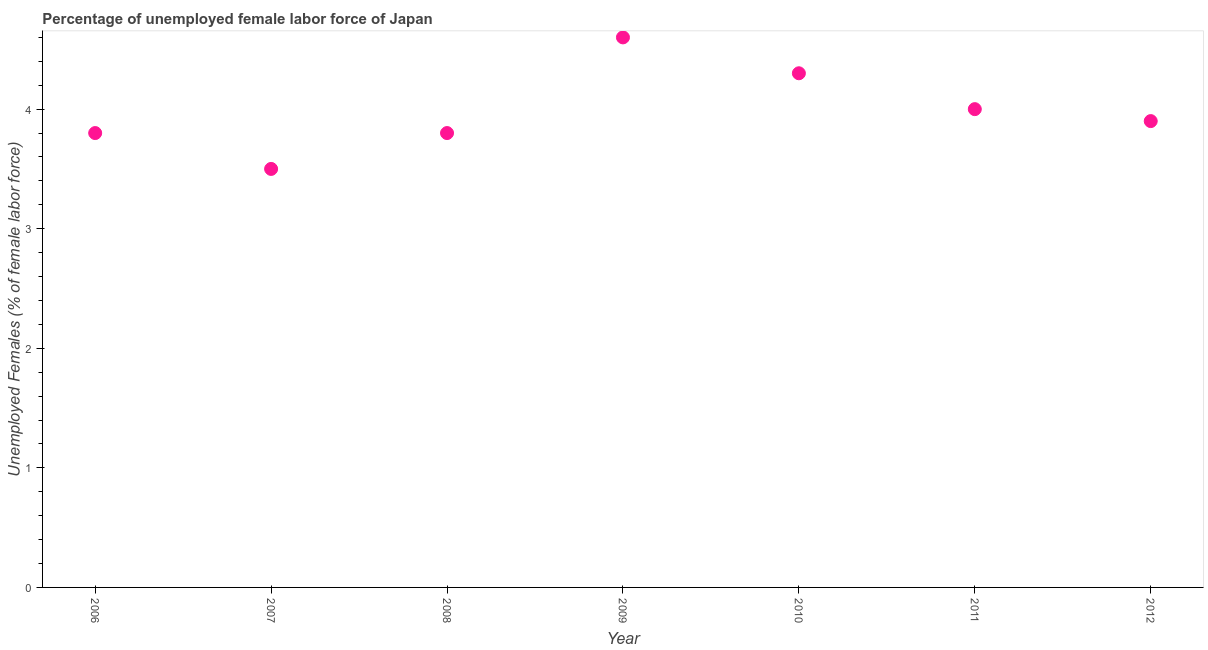What is the total unemployed female labour force in 2009?
Make the answer very short. 4.6. Across all years, what is the maximum total unemployed female labour force?
Your answer should be very brief. 4.6. What is the sum of the total unemployed female labour force?
Ensure brevity in your answer.  27.9. What is the difference between the total unemployed female labour force in 2007 and 2009?
Keep it short and to the point. -1.1. What is the average total unemployed female labour force per year?
Ensure brevity in your answer.  3.99. What is the median total unemployed female labour force?
Give a very brief answer. 3.9. In how many years, is the total unemployed female labour force greater than 0.8 %?
Offer a terse response. 7. What is the ratio of the total unemployed female labour force in 2007 to that in 2009?
Provide a short and direct response. 0.76. Is the total unemployed female labour force in 2010 less than that in 2012?
Ensure brevity in your answer.  No. Is the difference between the total unemployed female labour force in 2008 and 2009 greater than the difference between any two years?
Make the answer very short. No. What is the difference between the highest and the second highest total unemployed female labour force?
Your answer should be very brief. 0.3. Is the sum of the total unemployed female labour force in 2010 and 2012 greater than the maximum total unemployed female labour force across all years?
Give a very brief answer. Yes. What is the difference between the highest and the lowest total unemployed female labour force?
Provide a succinct answer. 1.1. Does the total unemployed female labour force monotonically increase over the years?
Ensure brevity in your answer.  No. How many dotlines are there?
Keep it short and to the point. 1. How many years are there in the graph?
Keep it short and to the point. 7. What is the difference between two consecutive major ticks on the Y-axis?
Provide a succinct answer. 1. Are the values on the major ticks of Y-axis written in scientific E-notation?
Provide a short and direct response. No. Does the graph contain any zero values?
Your response must be concise. No. What is the title of the graph?
Provide a succinct answer. Percentage of unemployed female labor force of Japan. What is the label or title of the X-axis?
Your response must be concise. Year. What is the label or title of the Y-axis?
Provide a short and direct response. Unemployed Females (% of female labor force). What is the Unemployed Females (% of female labor force) in 2006?
Your response must be concise. 3.8. What is the Unemployed Females (% of female labor force) in 2007?
Offer a terse response. 3.5. What is the Unemployed Females (% of female labor force) in 2008?
Offer a terse response. 3.8. What is the Unemployed Females (% of female labor force) in 2009?
Your answer should be compact. 4.6. What is the Unemployed Females (% of female labor force) in 2010?
Make the answer very short. 4.3. What is the Unemployed Females (% of female labor force) in 2011?
Your answer should be compact. 4. What is the Unemployed Females (% of female labor force) in 2012?
Your answer should be compact. 3.9. What is the difference between the Unemployed Females (% of female labor force) in 2006 and 2008?
Provide a short and direct response. 0. What is the difference between the Unemployed Females (% of female labor force) in 2006 and 2011?
Provide a short and direct response. -0.2. What is the difference between the Unemployed Females (% of female labor force) in 2007 and 2008?
Your answer should be very brief. -0.3. What is the difference between the Unemployed Females (% of female labor force) in 2007 and 2011?
Make the answer very short. -0.5. What is the difference between the Unemployed Females (% of female labor force) in 2009 and 2011?
Make the answer very short. 0.6. What is the difference between the Unemployed Females (% of female labor force) in 2010 and 2011?
Make the answer very short. 0.3. What is the ratio of the Unemployed Females (% of female labor force) in 2006 to that in 2007?
Give a very brief answer. 1.09. What is the ratio of the Unemployed Females (% of female labor force) in 2006 to that in 2009?
Offer a very short reply. 0.83. What is the ratio of the Unemployed Females (% of female labor force) in 2006 to that in 2010?
Your response must be concise. 0.88. What is the ratio of the Unemployed Females (% of female labor force) in 2006 to that in 2011?
Provide a succinct answer. 0.95. What is the ratio of the Unemployed Females (% of female labor force) in 2007 to that in 2008?
Ensure brevity in your answer.  0.92. What is the ratio of the Unemployed Females (% of female labor force) in 2007 to that in 2009?
Offer a terse response. 0.76. What is the ratio of the Unemployed Females (% of female labor force) in 2007 to that in 2010?
Keep it short and to the point. 0.81. What is the ratio of the Unemployed Females (% of female labor force) in 2007 to that in 2011?
Provide a short and direct response. 0.88. What is the ratio of the Unemployed Females (% of female labor force) in 2007 to that in 2012?
Ensure brevity in your answer.  0.9. What is the ratio of the Unemployed Females (% of female labor force) in 2008 to that in 2009?
Provide a short and direct response. 0.83. What is the ratio of the Unemployed Females (% of female labor force) in 2008 to that in 2010?
Provide a short and direct response. 0.88. What is the ratio of the Unemployed Females (% of female labor force) in 2009 to that in 2010?
Keep it short and to the point. 1.07. What is the ratio of the Unemployed Females (% of female labor force) in 2009 to that in 2011?
Ensure brevity in your answer.  1.15. What is the ratio of the Unemployed Females (% of female labor force) in 2009 to that in 2012?
Provide a succinct answer. 1.18. What is the ratio of the Unemployed Females (% of female labor force) in 2010 to that in 2011?
Provide a short and direct response. 1.07. What is the ratio of the Unemployed Females (% of female labor force) in 2010 to that in 2012?
Give a very brief answer. 1.1. 